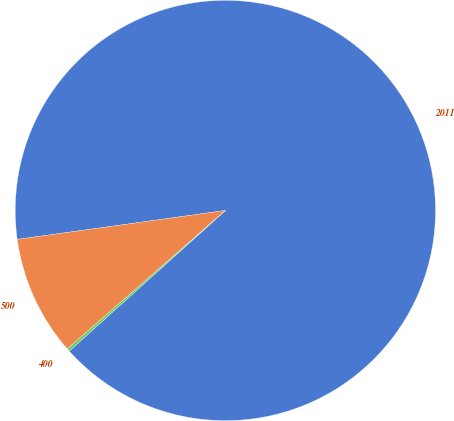Convert chart to OTSL. <chart><loc_0><loc_0><loc_500><loc_500><pie_chart><fcel>2011<fcel>500<fcel>400<nl><fcel>90.53%<fcel>9.25%<fcel>0.22%<nl></chart> 